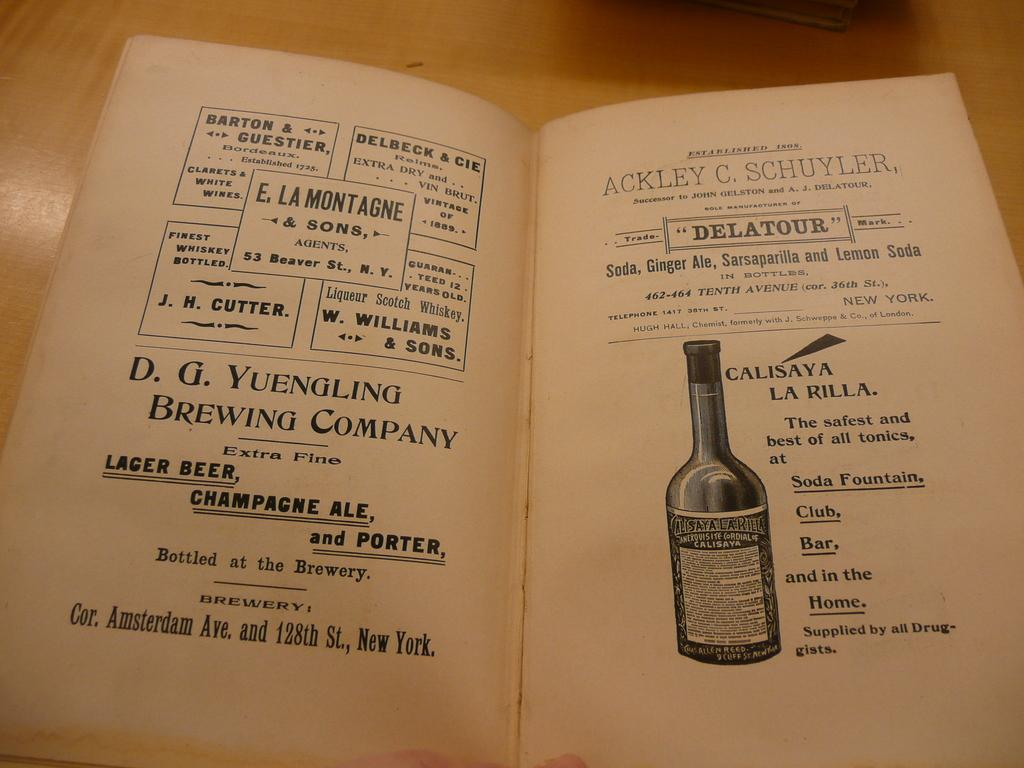<image>
Provide a brief description of the given image. A book is open to show Barton & Guestier in a box on the left side with a bottle of wine on the right page. 